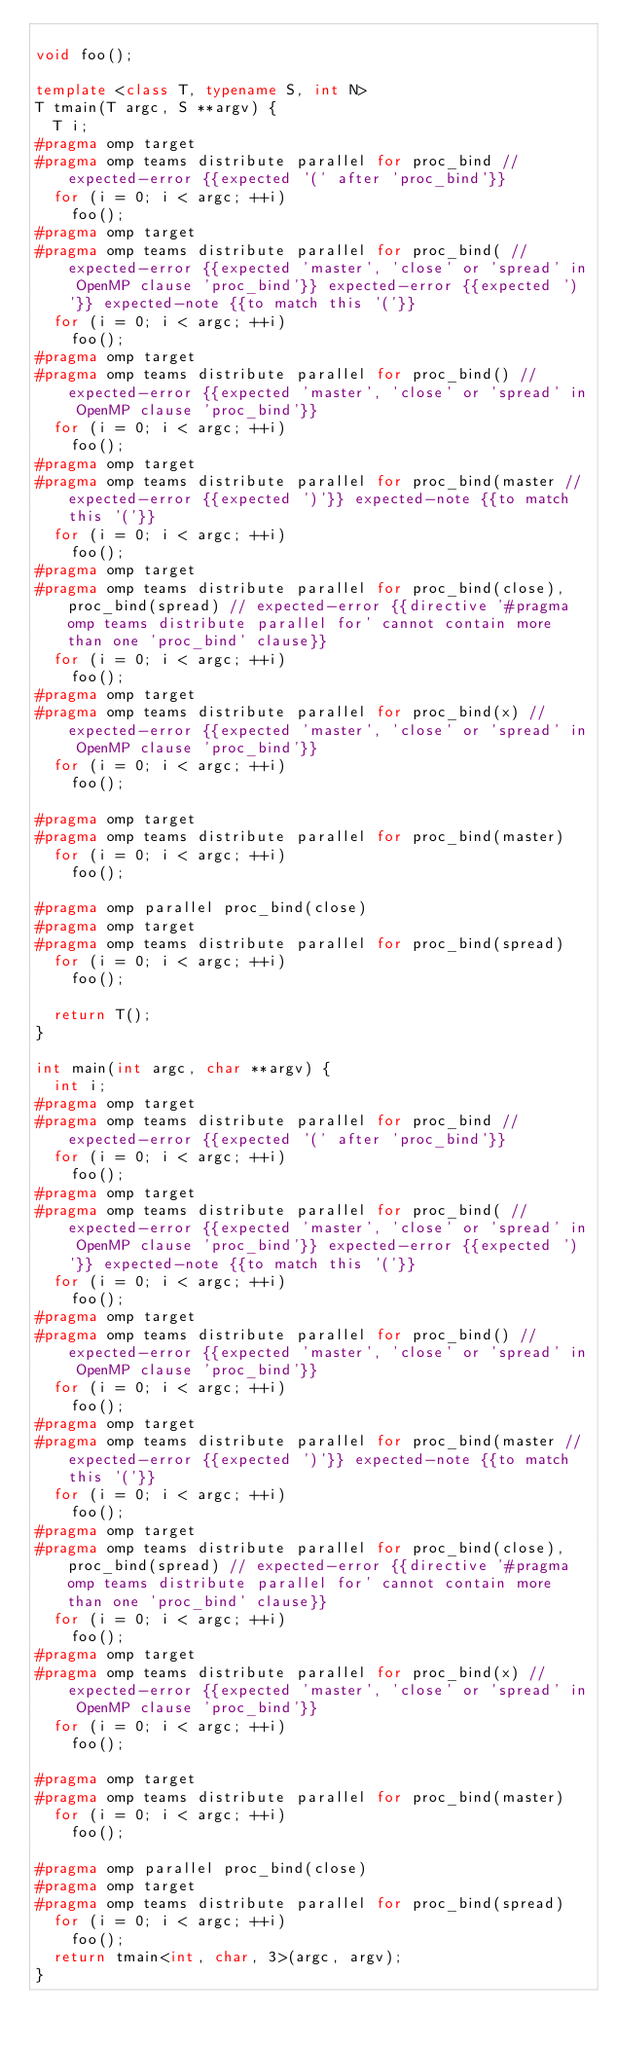<code> <loc_0><loc_0><loc_500><loc_500><_C++_>
void foo();

template <class T, typename S, int N>
T tmain(T argc, S **argv) {
  T i;
#pragma omp target
#pragma omp teams distribute parallel for proc_bind // expected-error {{expected '(' after 'proc_bind'}}
  for (i = 0; i < argc; ++i)
    foo();
#pragma omp target
#pragma omp teams distribute parallel for proc_bind( // expected-error {{expected 'master', 'close' or 'spread' in OpenMP clause 'proc_bind'}} expected-error {{expected ')'}} expected-note {{to match this '('}}
  for (i = 0; i < argc; ++i)
    foo();
#pragma omp target
#pragma omp teams distribute parallel for proc_bind() // expected-error {{expected 'master', 'close' or 'spread' in OpenMP clause 'proc_bind'}}
  for (i = 0; i < argc; ++i)
    foo();
#pragma omp target
#pragma omp teams distribute parallel for proc_bind(master // expected-error {{expected ')'}} expected-note {{to match this '('}}
  for (i = 0; i < argc; ++i)
    foo();
#pragma omp target
#pragma omp teams distribute parallel for proc_bind(close), proc_bind(spread) // expected-error {{directive '#pragma omp teams distribute parallel for' cannot contain more than one 'proc_bind' clause}}
  for (i = 0; i < argc; ++i)
    foo();
#pragma omp target
#pragma omp teams distribute parallel for proc_bind(x) // expected-error {{expected 'master', 'close' or 'spread' in OpenMP clause 'proc_bind'}}
  for (i = 0; i < argc; ++i)
    foo();

#pragma omp target
#pragma omp teams distribute parallel for proc_bind(master)
  for (i = 0; i < argc; ++i)
    foo();

#pragma omp parallel proc_bind(close)
#pragma omp target
#pragma omp teams distribute parallel for proc_bind(spread)
  for (i = 0; i < argc; ++i)
    foo();

  return T();
}

int main(int argc, char **argv) {
  int i;
#pragma omp target
#pragma omp teams distribute parallel for proc_bind // expected-error {{expected '(' after 'proc_bind'}}
  for (i = 0; i < argc; ++i)
    foo();
#pragma omp target
#pragma omp teams distribute parallel for proc_bind( // expected-error {{expected 'master', 'close' or 'spread' in OpenMP clause 'proc_bind'}} expected-error {{expected ')'}} expected-note {{to match this '('}}
  for (i = 0; i < argc; ++i)
    foo();
#pragma omp target
#pragma omp teams distribute parallel for proc_bind() // expected-error {{expected 'master', 'close' or 'spread' in OpenMP clause 'proc_bind'}}
  for (i = 0; i < argc; ++i)
    foo();
#pragma omp target
#pragma omp teams distribute parallel for proc_bind(master // expected-error {{expected ')'}} expected-note {{to match this '('}}
  for (i = 0; i < argc; ++i)
    foo();
#pragma omp target
#pragma omp teams distribute parallel for proc_bind(close), proc_bind(spread) // expected-error {{directive '#pragma omp teams distribute parallel for' cannot contain more than one 'proc_bind' clause}}
  for (i = 0; i < argc; ++i)
    foo();
#pragma omp target
#pragma omp teams distribute parallel for proc_bind(x) // expected-error {{expected 'master', 'close' or 'spread' in OpenMP clause 'proc_bind'}}
  for (i = 0; i < argc; ++i)
    foo();

#pragma omp target
#pragma omp teams distribute parallel for proc_bind(master)
  for (i = 0; i < argc; ++i)
    foo();

#pragma omp parallel proc_bind(close)
#pragma omp target
#pragma omp teams distribute parallel for proc_bind(spread)
  for (i = 0; i < argc; ++i)
    foo();
  return tmain<int, char, 3>(argc, argv);
}
</code> 